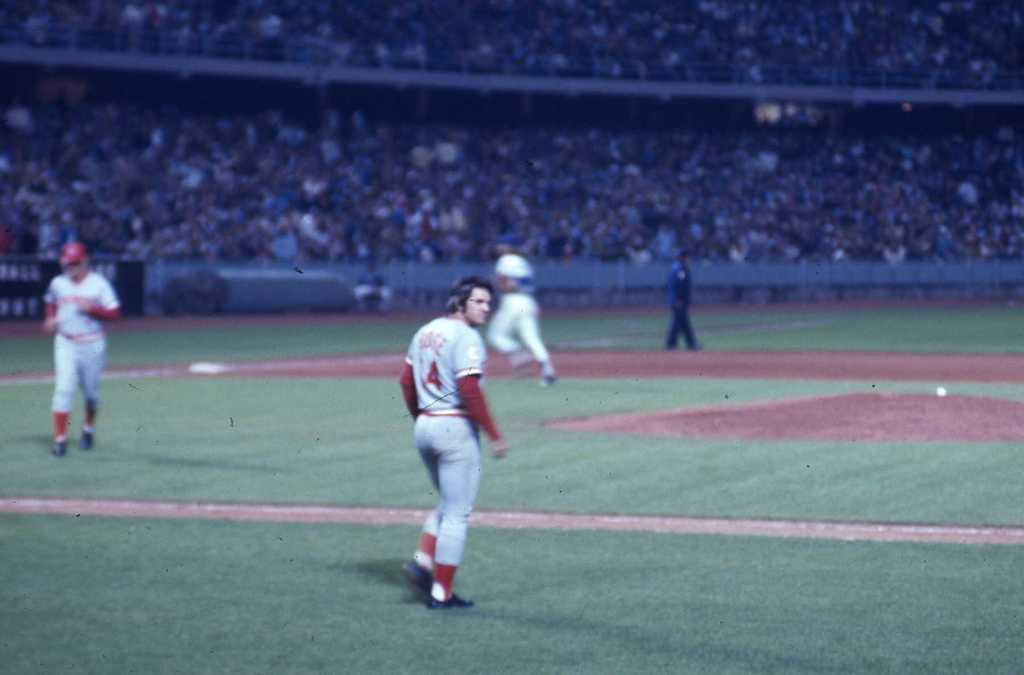<image>
Write a terse but informative summary of the picture. Some baseball players are on a field, including one who is wearing a Number 4 on his uniform.. 